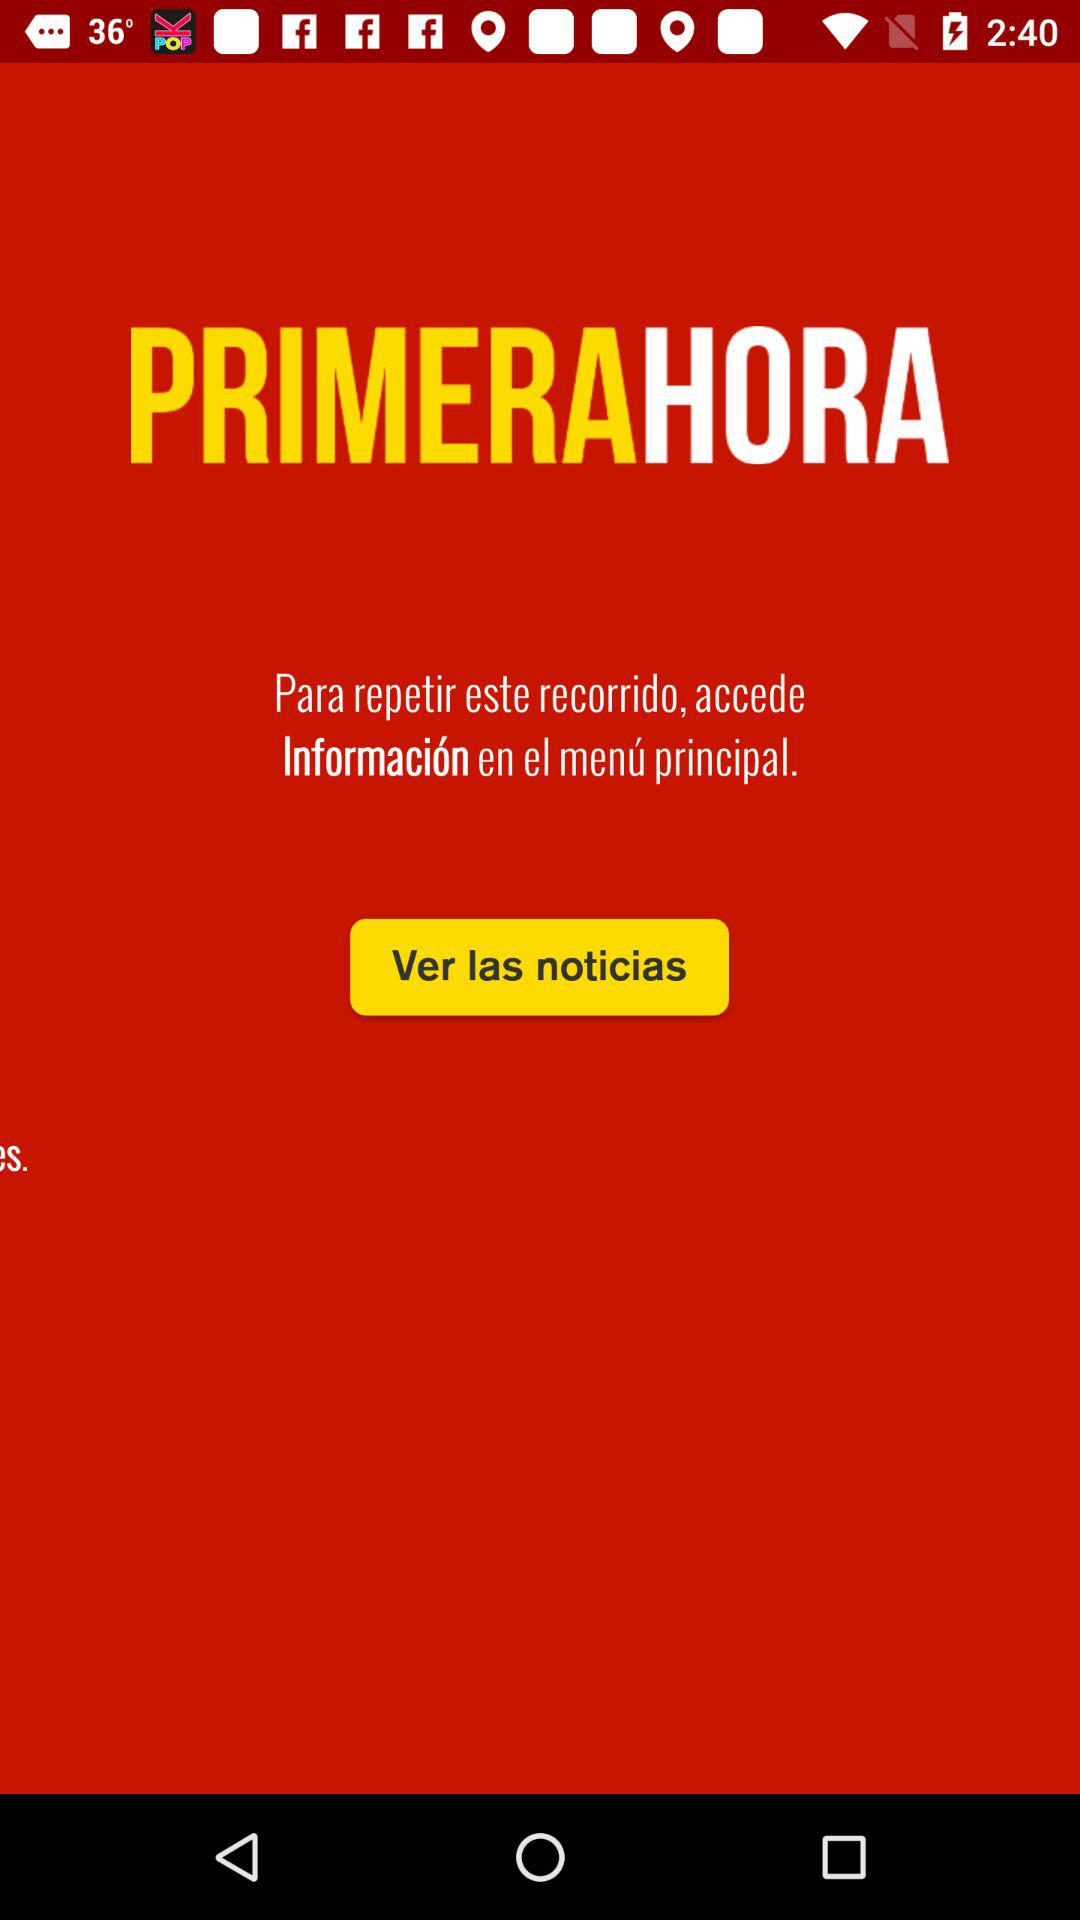What is the application name? The application name is "PRIMERAHORA". 